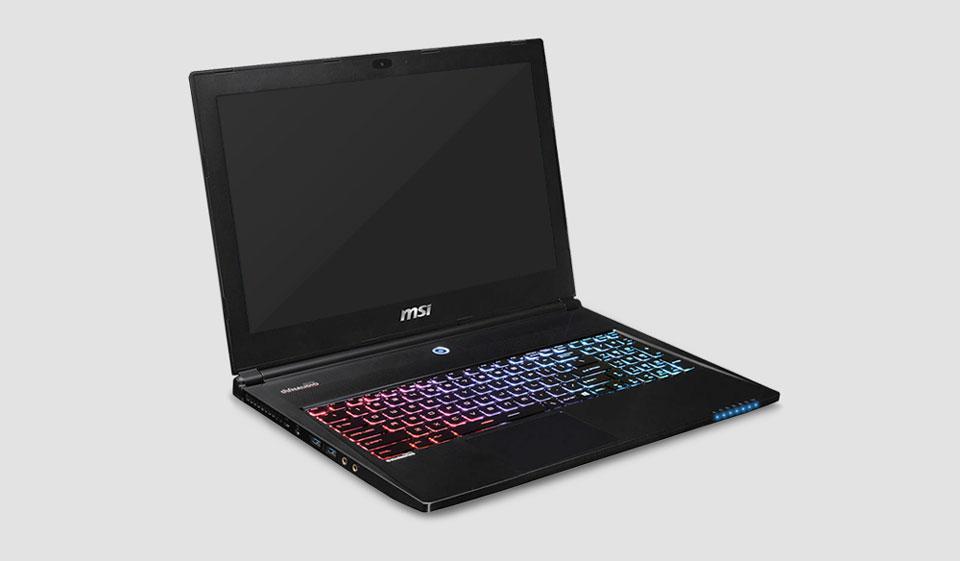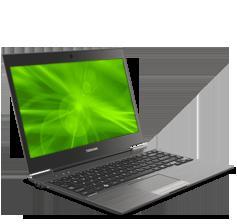The first image is the image on the left, the second image is the image on the right. For the images shown, is this caption "One photo contains multiple laptops." true? Answer yes or no. No. The first image is the image on the left, the second image is the image on the right. For the images shown, is this caption "Each image contains exactly one laptop-type device." true? Answer yes or no. Yes. 